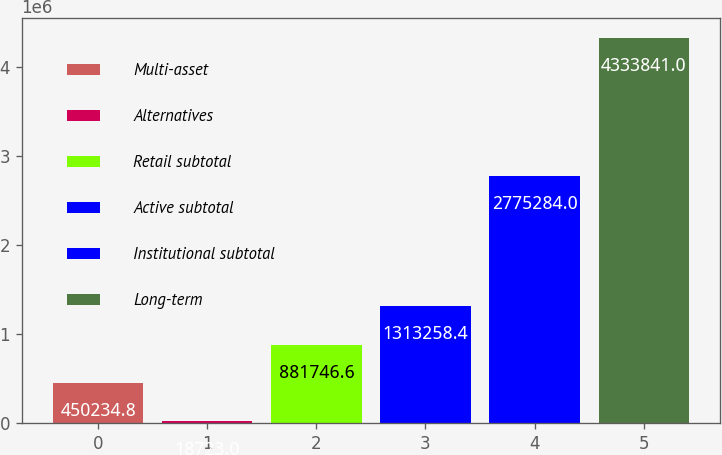<chart> <loc_0><loc_0><loc_500><loc_500><bar_chart><fcel>Multi-asset<fcel>Alternatives<fcel>Retail subtotal<fcel>Active subtotal<fcel>Institutional subtotal<fcel>Long-term<nl><fcel>450235<fcel>18723<fcel>881747<fcel>1.31326e+06<fcel>2.77528e+06<fcel>4.33384e+06<nl></chart> 